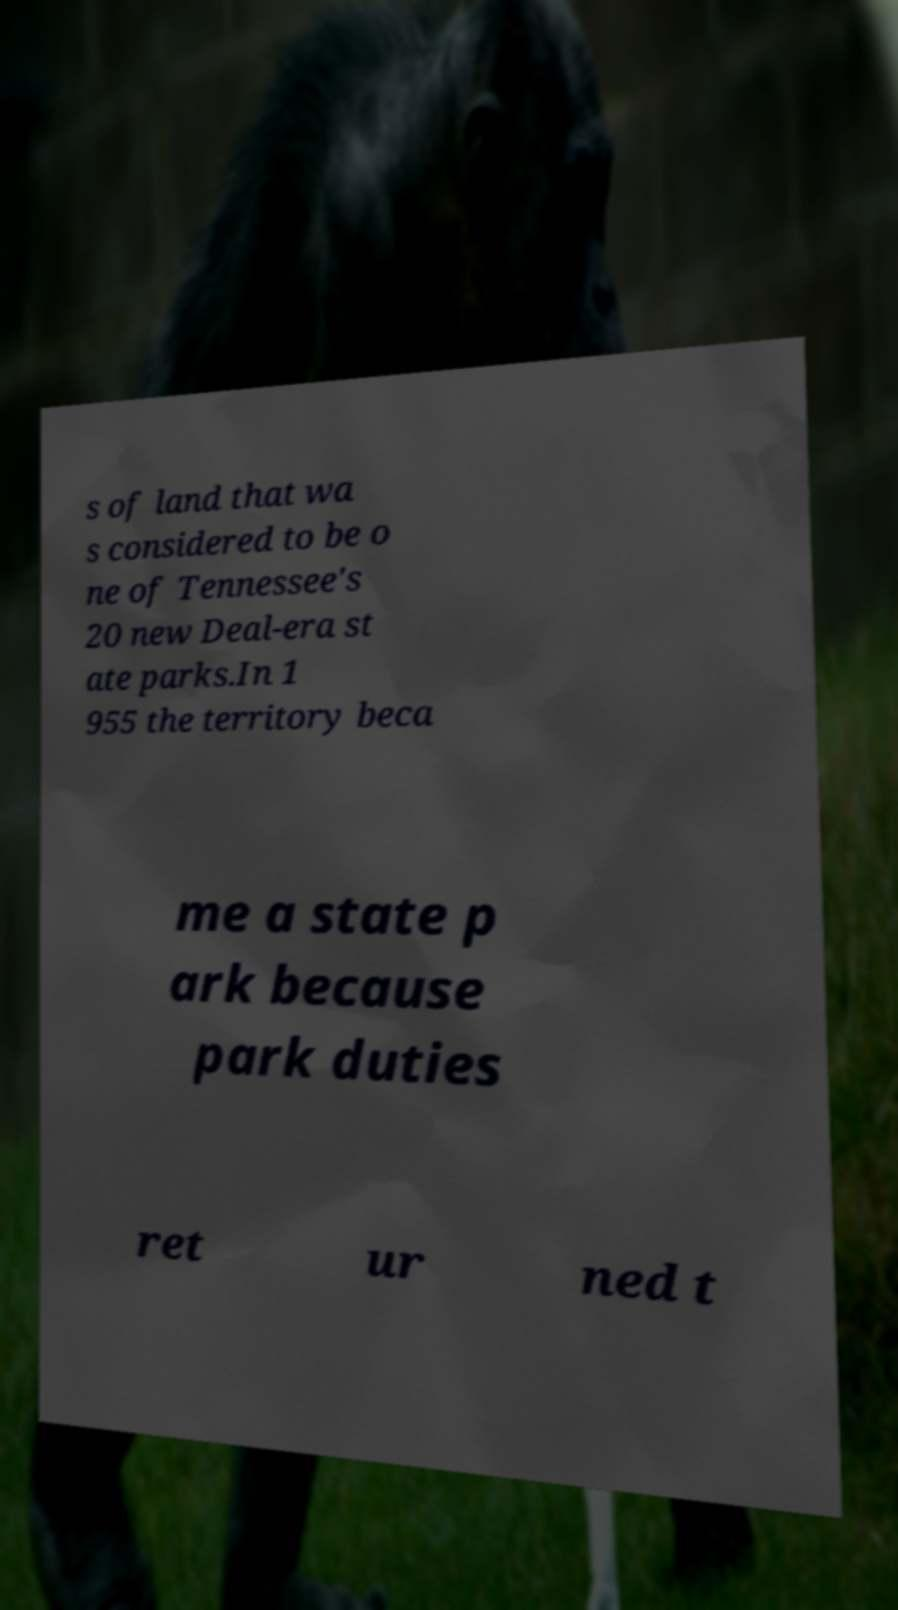Please identify and transcribe the text found in this image. s of land that wa s considered to be o ne of Tennessee's 20 new Deal-era st ate parks.In 1 955 the territory beca me a state p ark because park duties ret ur ned t 